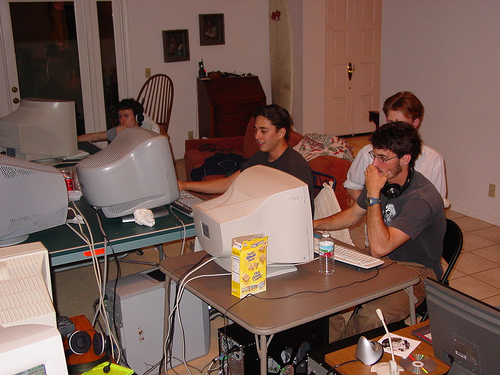What details suggest the activities they're engaging in might be collaborative or competitive? The proximity of the computer monitors, the orientation of the individuals towards their screens, while still being in close quarters, implies collaboration or competition. The presence of snacks and the informal dress code point to an extended session of interaction, which could be characteristic of both collaborative projects like a hackathon or competitive gaming like a LAN party. 